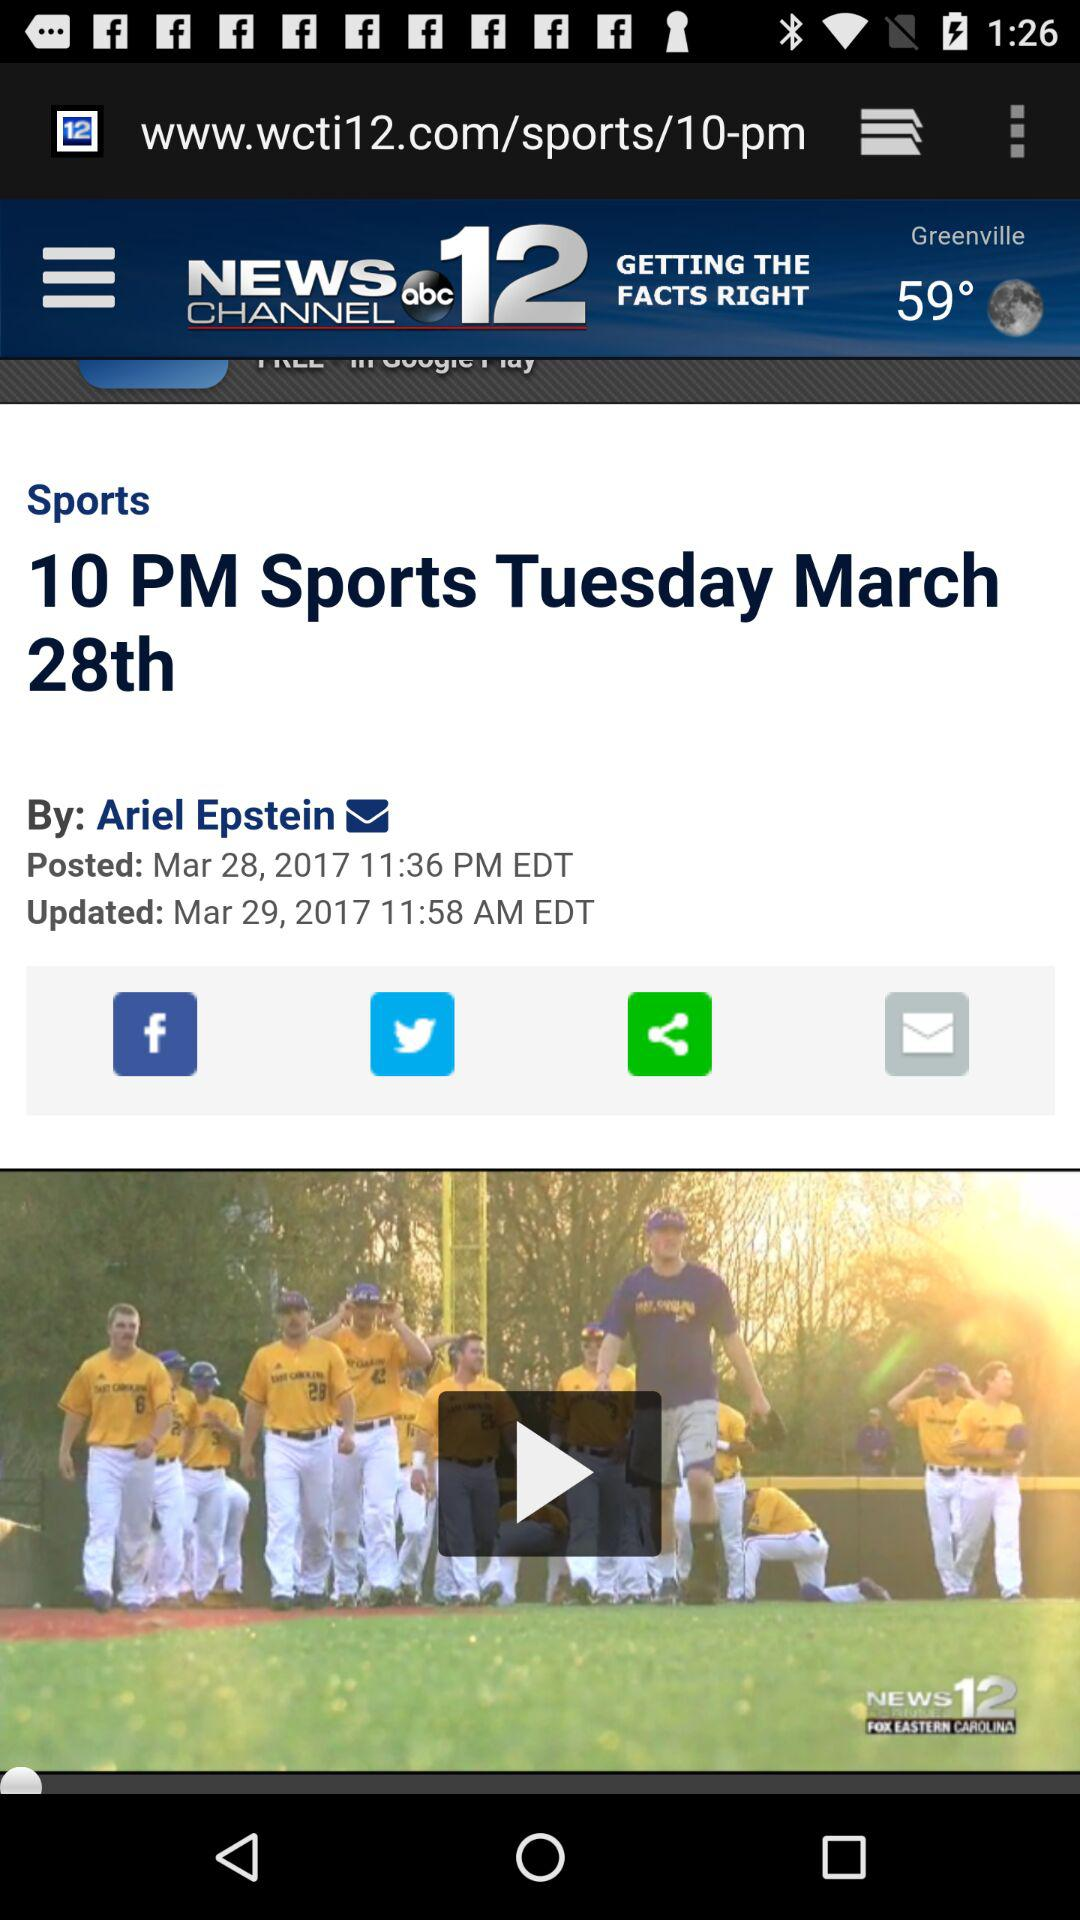What is the date and time when the news was posted? The news was posted on March 28, 2017 at 11:36 p.m. EDT. 